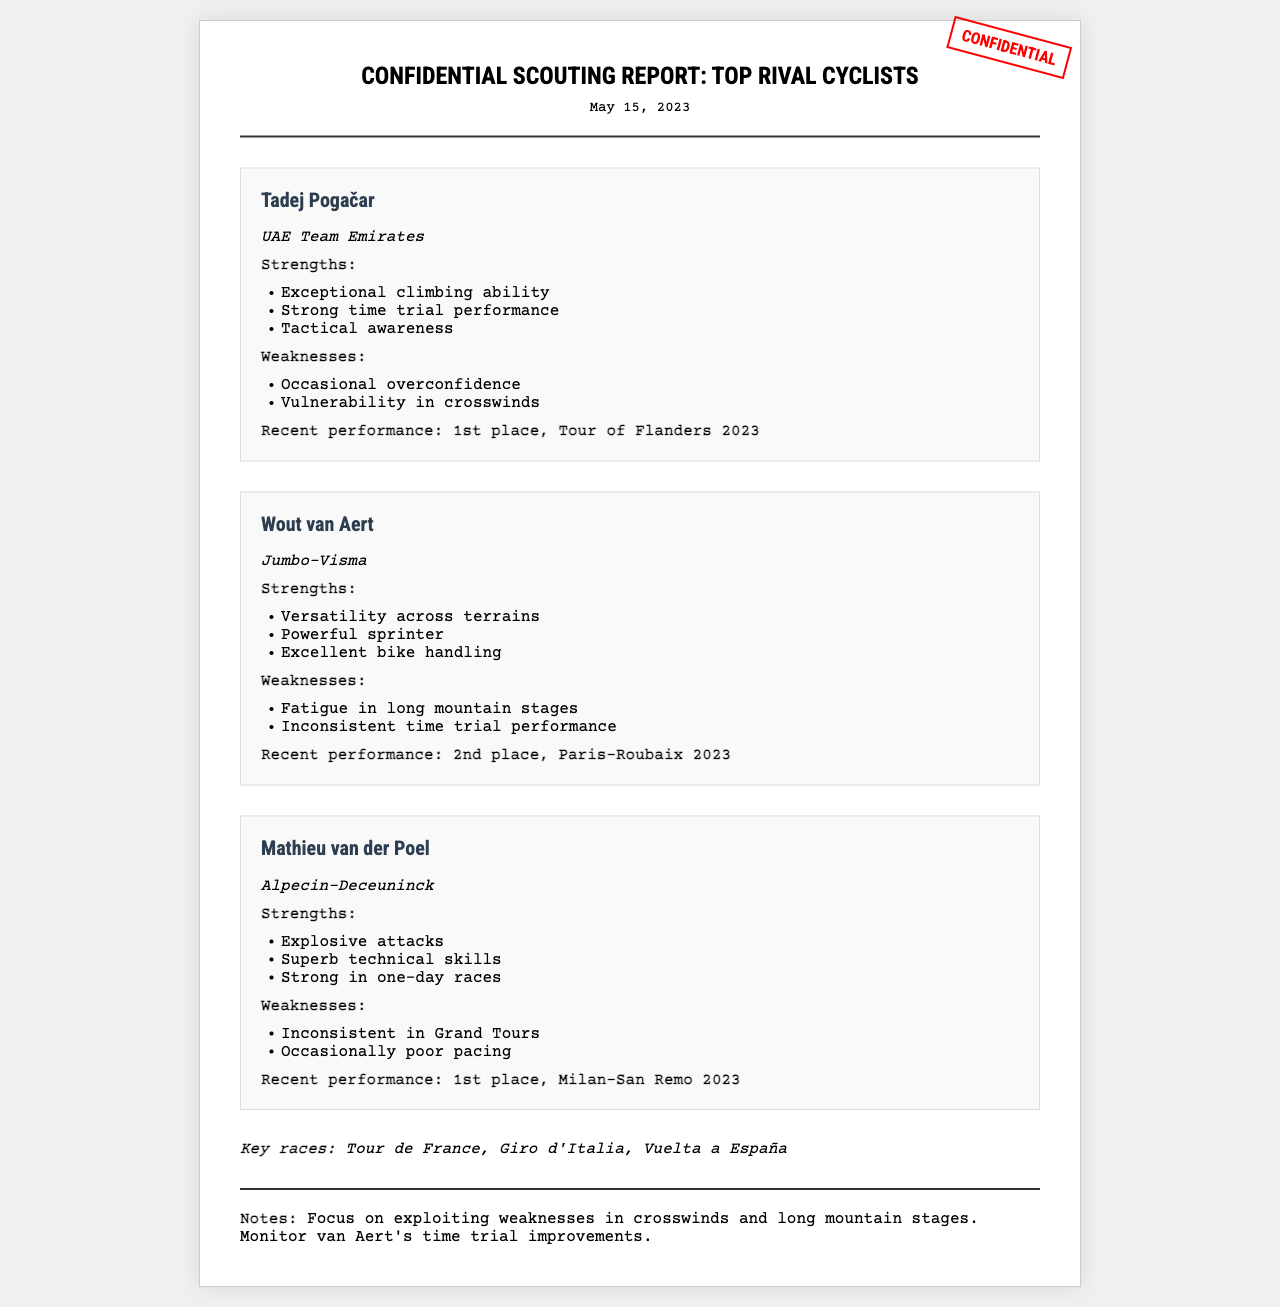What is the date of the report? The date of the report is mentioned at the top of the document.
Answer: May 15, 2023 Who is the team of Tadej Pogačar? Tadej Pogačar's team is specified in the document under his name.
Answer: UAE Team Emirates What is Wout van Aert's recent performance? The recent performance details are provided for each cyclist in the document.
Answer: 2nd place, Paris-Roubaix 2023 What weakness is mentioned for Mathieu van der Poel? Weaknesses are listed for each cyclist in the document.
Answer: Inconsistent in Grand Tours Which cyclist excels in time trials? The strengths of each cyclist are outlined, indicating their abilities.
Answer: Tadej Pogačar What key races are mentioned in the report? Key races are listed in a specific section of the document.
Answer: Tour de France, Giro d'Italia, Vuelta a España What specific advice is provided in the notes? The notes section summarizes strategic recommendations based on cyclists' weaknesses.
Answer: Focus on exploiting weaknesses in crosswinds and long mountain stages How many strengths are listed for Wout van Aert? The strengths are provided in a bullet point format, allowing for easy counting.
Answer: Three 